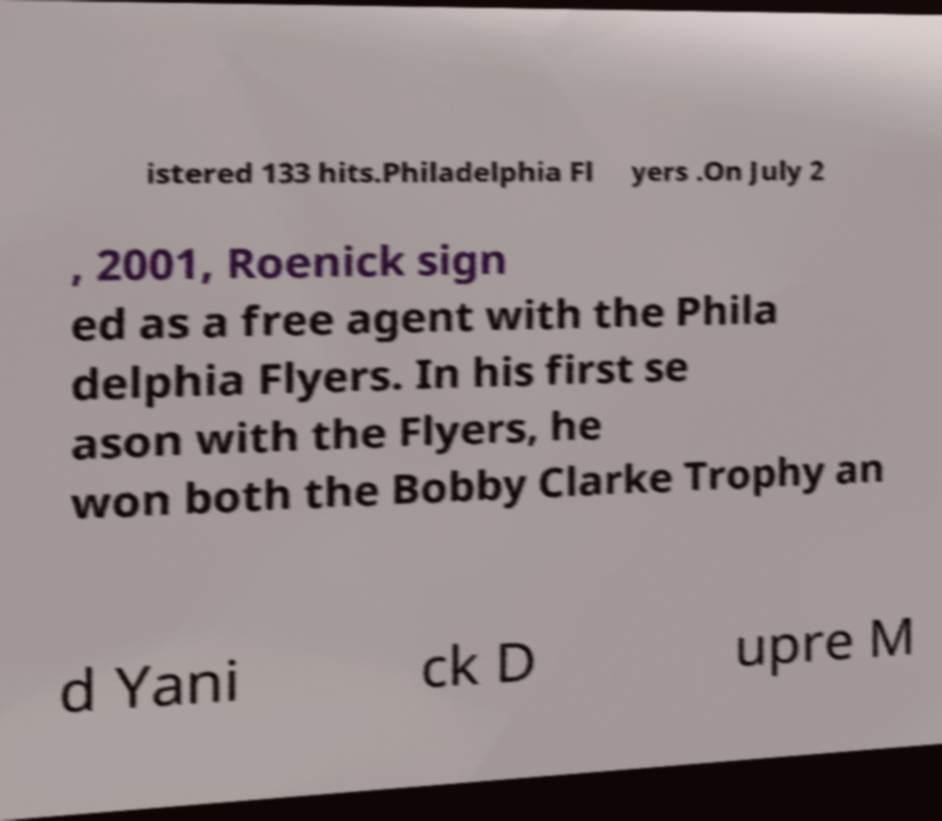Please identify and transcribe the text found in this image. istered 133 hits.Philadelphia Fl yers .On July 2 , 2001, Roenick sign ed as a free agent with the Phila delphia Flyers. In his first se ason with the Flyers, he won both the Bobby Clarke Trophy an d Yani ck D upre M 